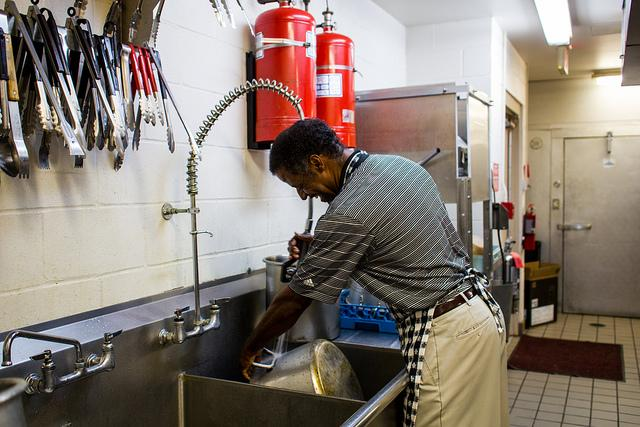What items are hanging on the wall? tongs 